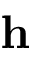Convert formula to latex. <formula><loc_0><loc_0><loc_500><loc_500>h</formula> 